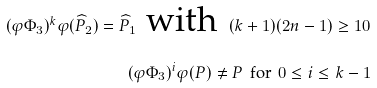<formula> <loc_0><loc_0><loc_500><loc_500>( \varphi \Phi _ { 3 } ) ^ { k } \varphi ( \widehat { P } _ { 2 } ) = \widehat { P } _ { 1 } \text { with } \, ( k + 1 ) ( 2 n - 1 ) \geq 1 0 \\ ( \varphi \Phi _ { 3 } ) ^ { i } \varphi ( P ) \not = P \, \text { for } \, 0 \leq i \leq k - 1</formula> 